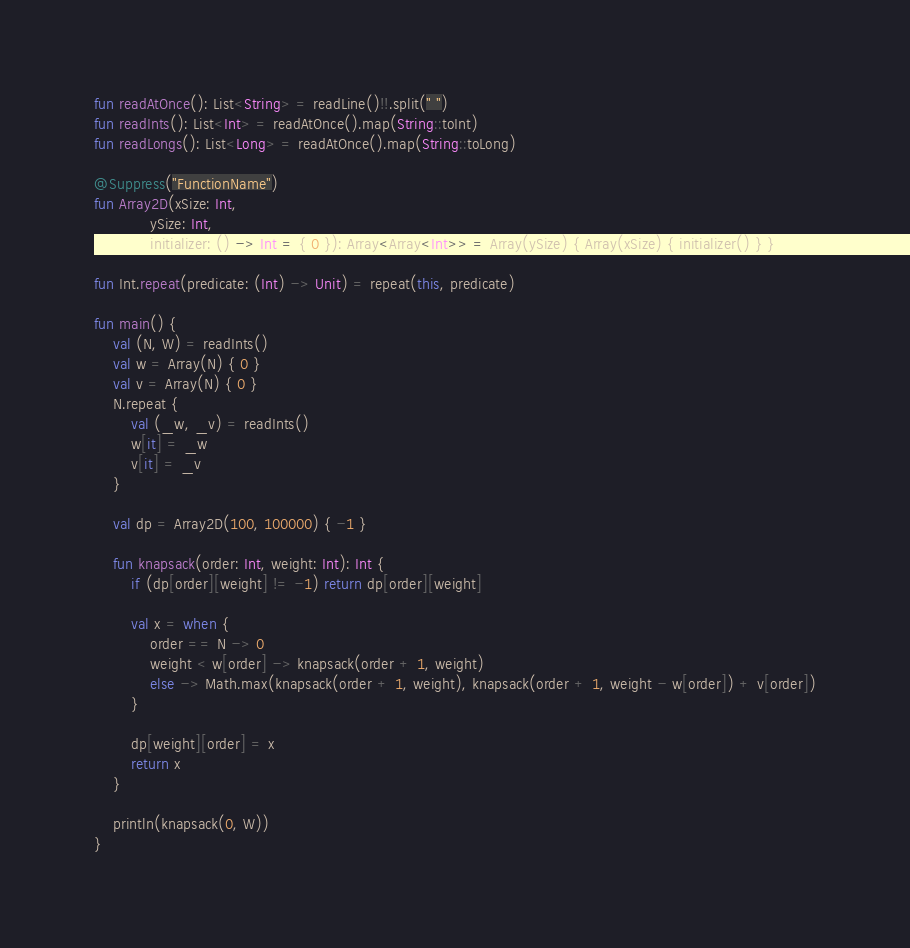Convert code to text. <code><loc_0><loc_0><loc_500><loc_500><_Kotlin_>fun readAtOnce(): List<String> = readLine()!!.split(" ")
fun readInts(): List<Int> = readAtOnce().map(String::toInt)
fun readLongs(): List<Long> = readAtOnce().map(String::toLong)

@Suppress("FunctionName")
fun Array2D(xSize: Int,
            ySize: Int,
            initializer: () -> Int = { 0 }): Array<Array<Int>> = Array(ySize) { Array(xSize) { initializer() } }

fun Int.repeat(predicate: (Int) -> Unit) = repeat(this, predicate)

fun main() {
    val (N, W) = readInts()
    val w = Array(N) { 0 }
    val v = Array(N) { 0 }
    N.repeat {
        val (_w, _v) = readInts()
        w[it] = _w
        v[it] = _v
    }

    val dp = Array2D(100, 100000) { -1 }

    fun knapsack(order: Int, weight: Int): Int {
        if (dp[order][weight] != -1) return dp[order][weight]

        val x = when {
            order == N -> 0
            weight < w[order] -> knapsack(order + 1, weight)
            else -> Math.max(knapsack(order + 1, weight), knapsack(order + 1, weight - w[order]) + v[order])
        }

        dp[weight][order] = x
        return x
    }

    println(knapsack(0, W))
}</code> 